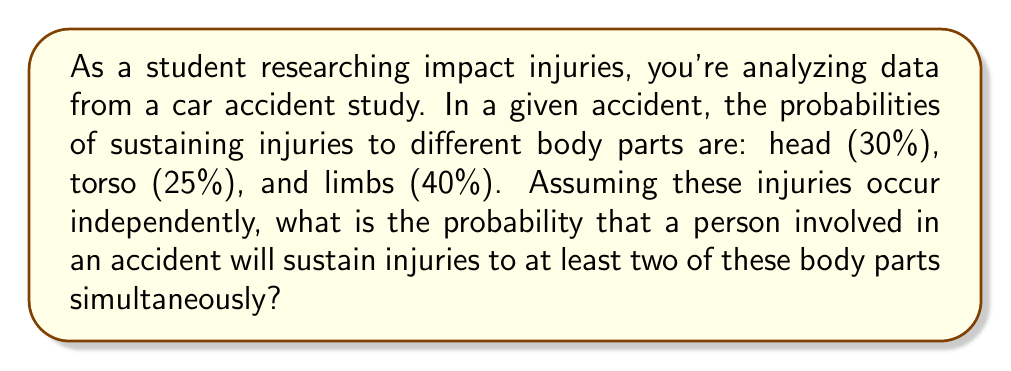Could you help me with this problem? To solve this problem, we'll use the concept of probability of multiple independent events and the complement rule.

Let's define the events:
H: Head injury (P(H) = 0.30)
T: Torso injury (P(T) = 0.25)
L: Limb injury (P(L) = 0.40)

We want to find the probability of at least two injuries occurring simultaneously. It's easier to calculate the complement of this event: the probability of having one or no injuries.

1. Probability of no injuries:
   P(no injuries) = $(1 - 0.30) \times (1 - 0.25) \times (1 - 0.40) = 0.70 \times 0.75 \times 0.60 = 0.315$

2. Probability of exactly one injury:
   P(only H) = $0.30 \times 0.75 \times 0.60 = 0.135$
   P(only T) = $0.70 \times 0.25 \times 0.60 = 0.105$
   P(only L) = $0.70 \times 0.75 \times 0.40 = 0.210$
   
   P(exactly one injury) = $0.135 + 0.105 + 0.210 = 0.450$

3. Probability of one or no injuries:
   P(one or no injuries) = $0.315 + 0.450 = 0.765$

4. Probability of at least two injuries (our desired result):
   P(at least two injuries) = $1 - P(one or no injuries) = 1 - 0.765 = 0.235$

Therefore, the probability of sustaining injuries to at least two body parts simultaneously is 0.235 or 23.5%.
Answer: The probability of sustaining injuries to at least two body parts simultaneously is $0.235$ or $23.5\%$. 